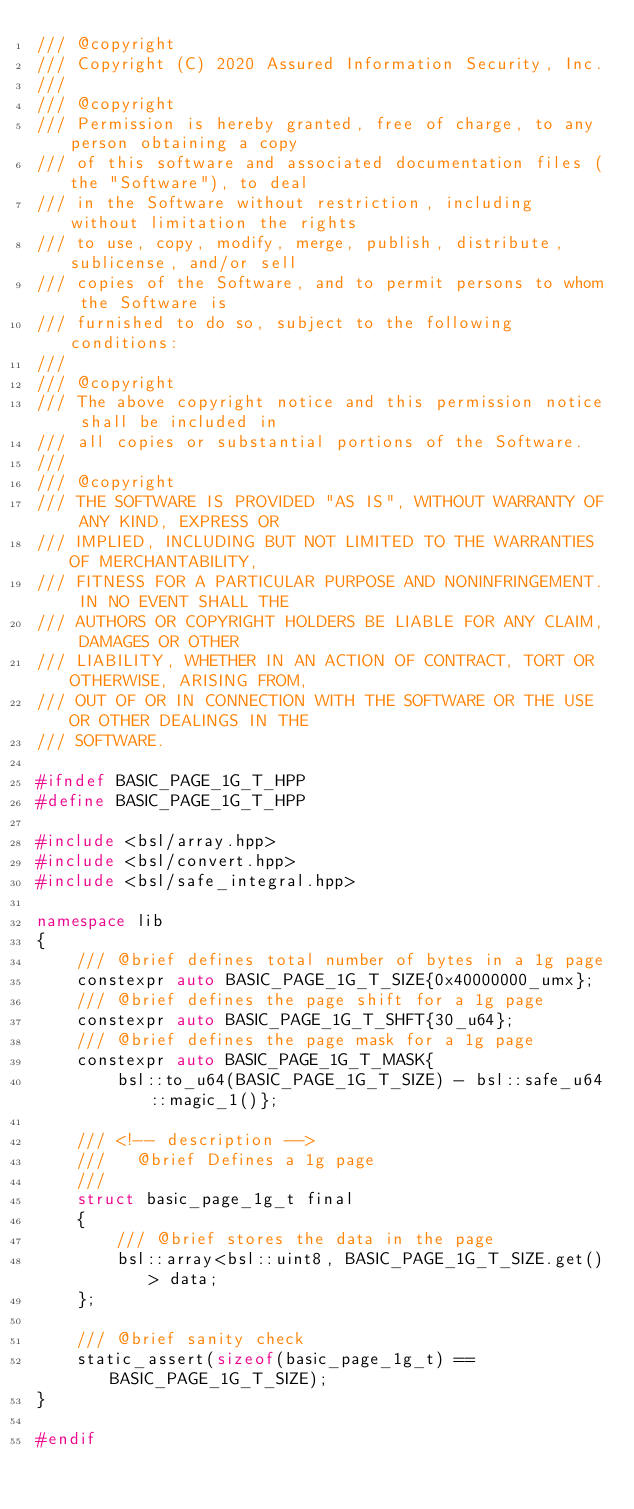Convert code to text. <code><loc_0><loc_0><loc_500><loc_500><_C++_>/// @copyright
/// Copyright (C) 2020 Assured Information Security, Inc.
///
/// @copyright
/// Permission is hereby granted, free of charge, to any person obtaining a copy
/// of this software and associated documentation files (the "Software"), to deal
/// in the Software without restriction, including without limitation the rights
/// to use, copy, modify, merge, publish, distribute, sublicense, and/or sell
/// copies of the Software, and to permit persons to whom the Software is
/// furnished to do so, subject to the following conditions:
///
/// @copyright
/// The above copyright notice and this permission notice shall be included in
/// all copies or substantial portions of the Software.
///
/// @copyright
/// THE SOFTWARE IS PROVIDED "AS IS", WITHOUT WARRANTY OF ANY KIND, EXPRESS OR
/// IMPLIED, INCLUDING BUT NOT LIMITED TO THE WARRANTIES OF MERCHANTABILITY,
/// FITNESS FOR A PARTICULAR PURPOSE AND NONINFRINGEMENT. IN NO EVENT SHALL THE
/// AUTHORS OR COPYRIGHT HOLDERS BE LIABLE FOR ANY CLAIM, DAMAGES OR OTHER
/// LIABILITY, WHETHER IN AN ACTION OF CONTRACT, TORT OR OTHERWISE, ARISING FROM,
/// OUT OF OR IN CONNECTION WITH THE SOFTWARE OR THE USE OR OTHER DEALINGS IN THE
/// SOFTWARE.

#ifndef BASIC_PAGE_1G_T_HPP
#define BASIC_PAGE_1G_T_HPP

#include <bsl/array.hpp>
#include <bsl/convert.hpp>
#include <bsl/safe_integral.hpp>

namespace lib
{
    /// @brief defines total number of bytes in a 1g page
    constexpr auto BASIC_PAGE_1G_T_SIZE{0x40000000_umx};
    /// @brief defines the page shift for a 1g page
    constexpr auto BASIC_PAGE_1G_T_SHFT{30_u64};
    /// @brief defines the page mask for a 1g page
    constexpr auto BASIC_PAGE_1G_T_MASK{
        bsl::to_u64(BASIC_PAGE_1G_T_SIZE) - bsl::safe_u64::magic_1()};

    /// <!-- description -->
    ///   @brief Defines a 1g page
    ///
    struct basic_page_1g_t final
    {
        /// @brief stores the data in the page
        bsl::array<bsl::uint8, BASIC_PAGE_1G_T_SIZE.get()> data;
    };

    /// @brief sanity check
    static_assert(sizeof(basic_page_1g_t) == BASIC_PAGE_1G_T_SIZE);
}

#endif
</code> 